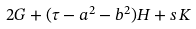<formula> <loc_0><loc_0><loc_500><loc_500>2 G + ( \tau - a ^ { 2 } - b ^ { 2 } ) H + s \, K</formula> 